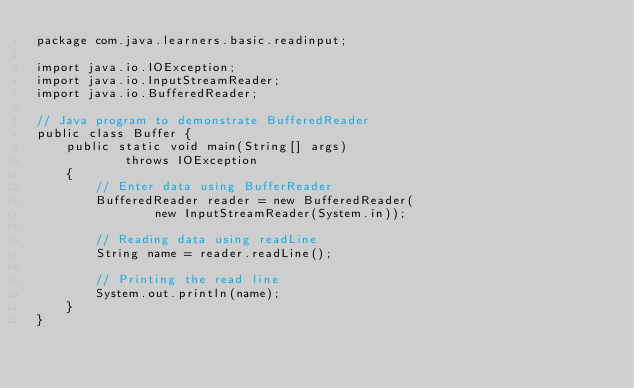<code> <loc_0><loc_0><loc_500><loc_500><_Java_>package com.java.learners.basic.readinput;

import java.io.IOException;
import java.io.InputStreamReader;
import java.io.BufferedReader;

// Java program to demonstrate BufferedReader
public class Buffer {
    public static void main(String[] args)
            throws IOException
    {
        // Enter data using BufferReader
        BufferedReader reader = new BufferedReader(
                new InputStreamReader(System.in));

        // Reading data using readLine
        String name = reader.readLine();

        // Printing the read line
        System.out.println(name);
    }
}</code> 